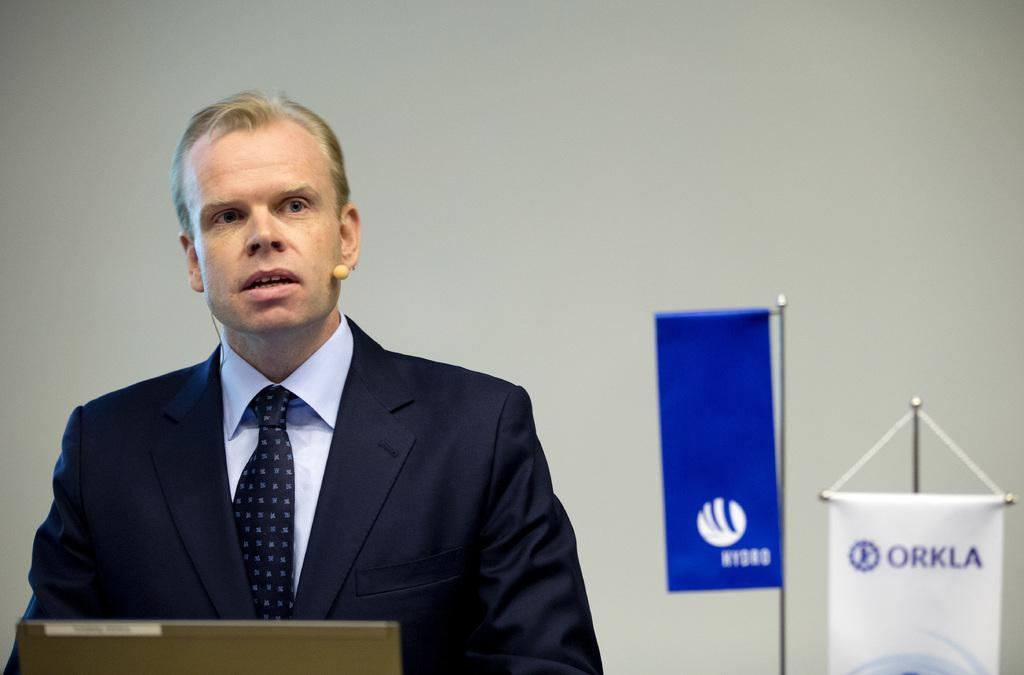What is the person in the image wearing? The person in the image is wearing a suit. What can be seen in the background of the image? There is a wall and two banners with text in the background of the image. What type of egg is being served in the image? There is no egg present in the image. Can you describe the behavior of the squirrel in the image? There is no squirrel present in the image. 